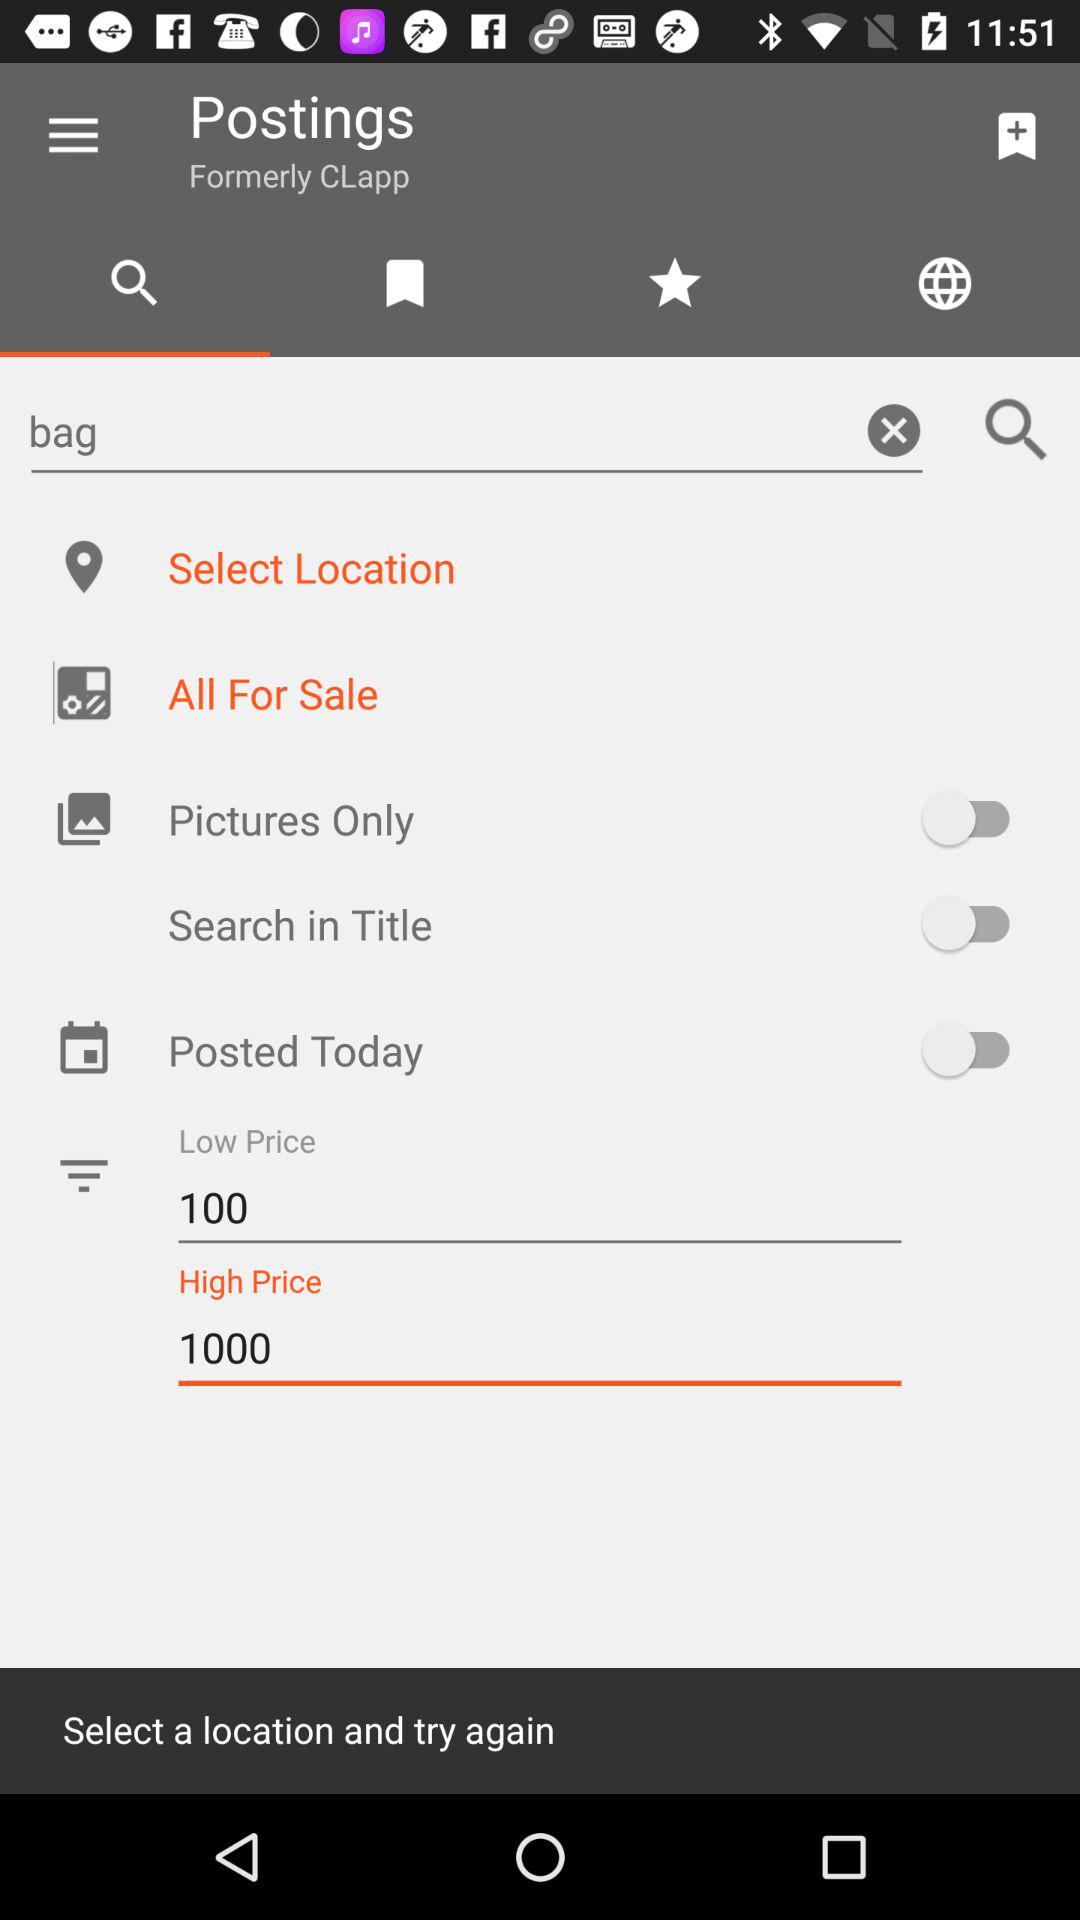What is the item in the search field? The item in the search field is a bag. 